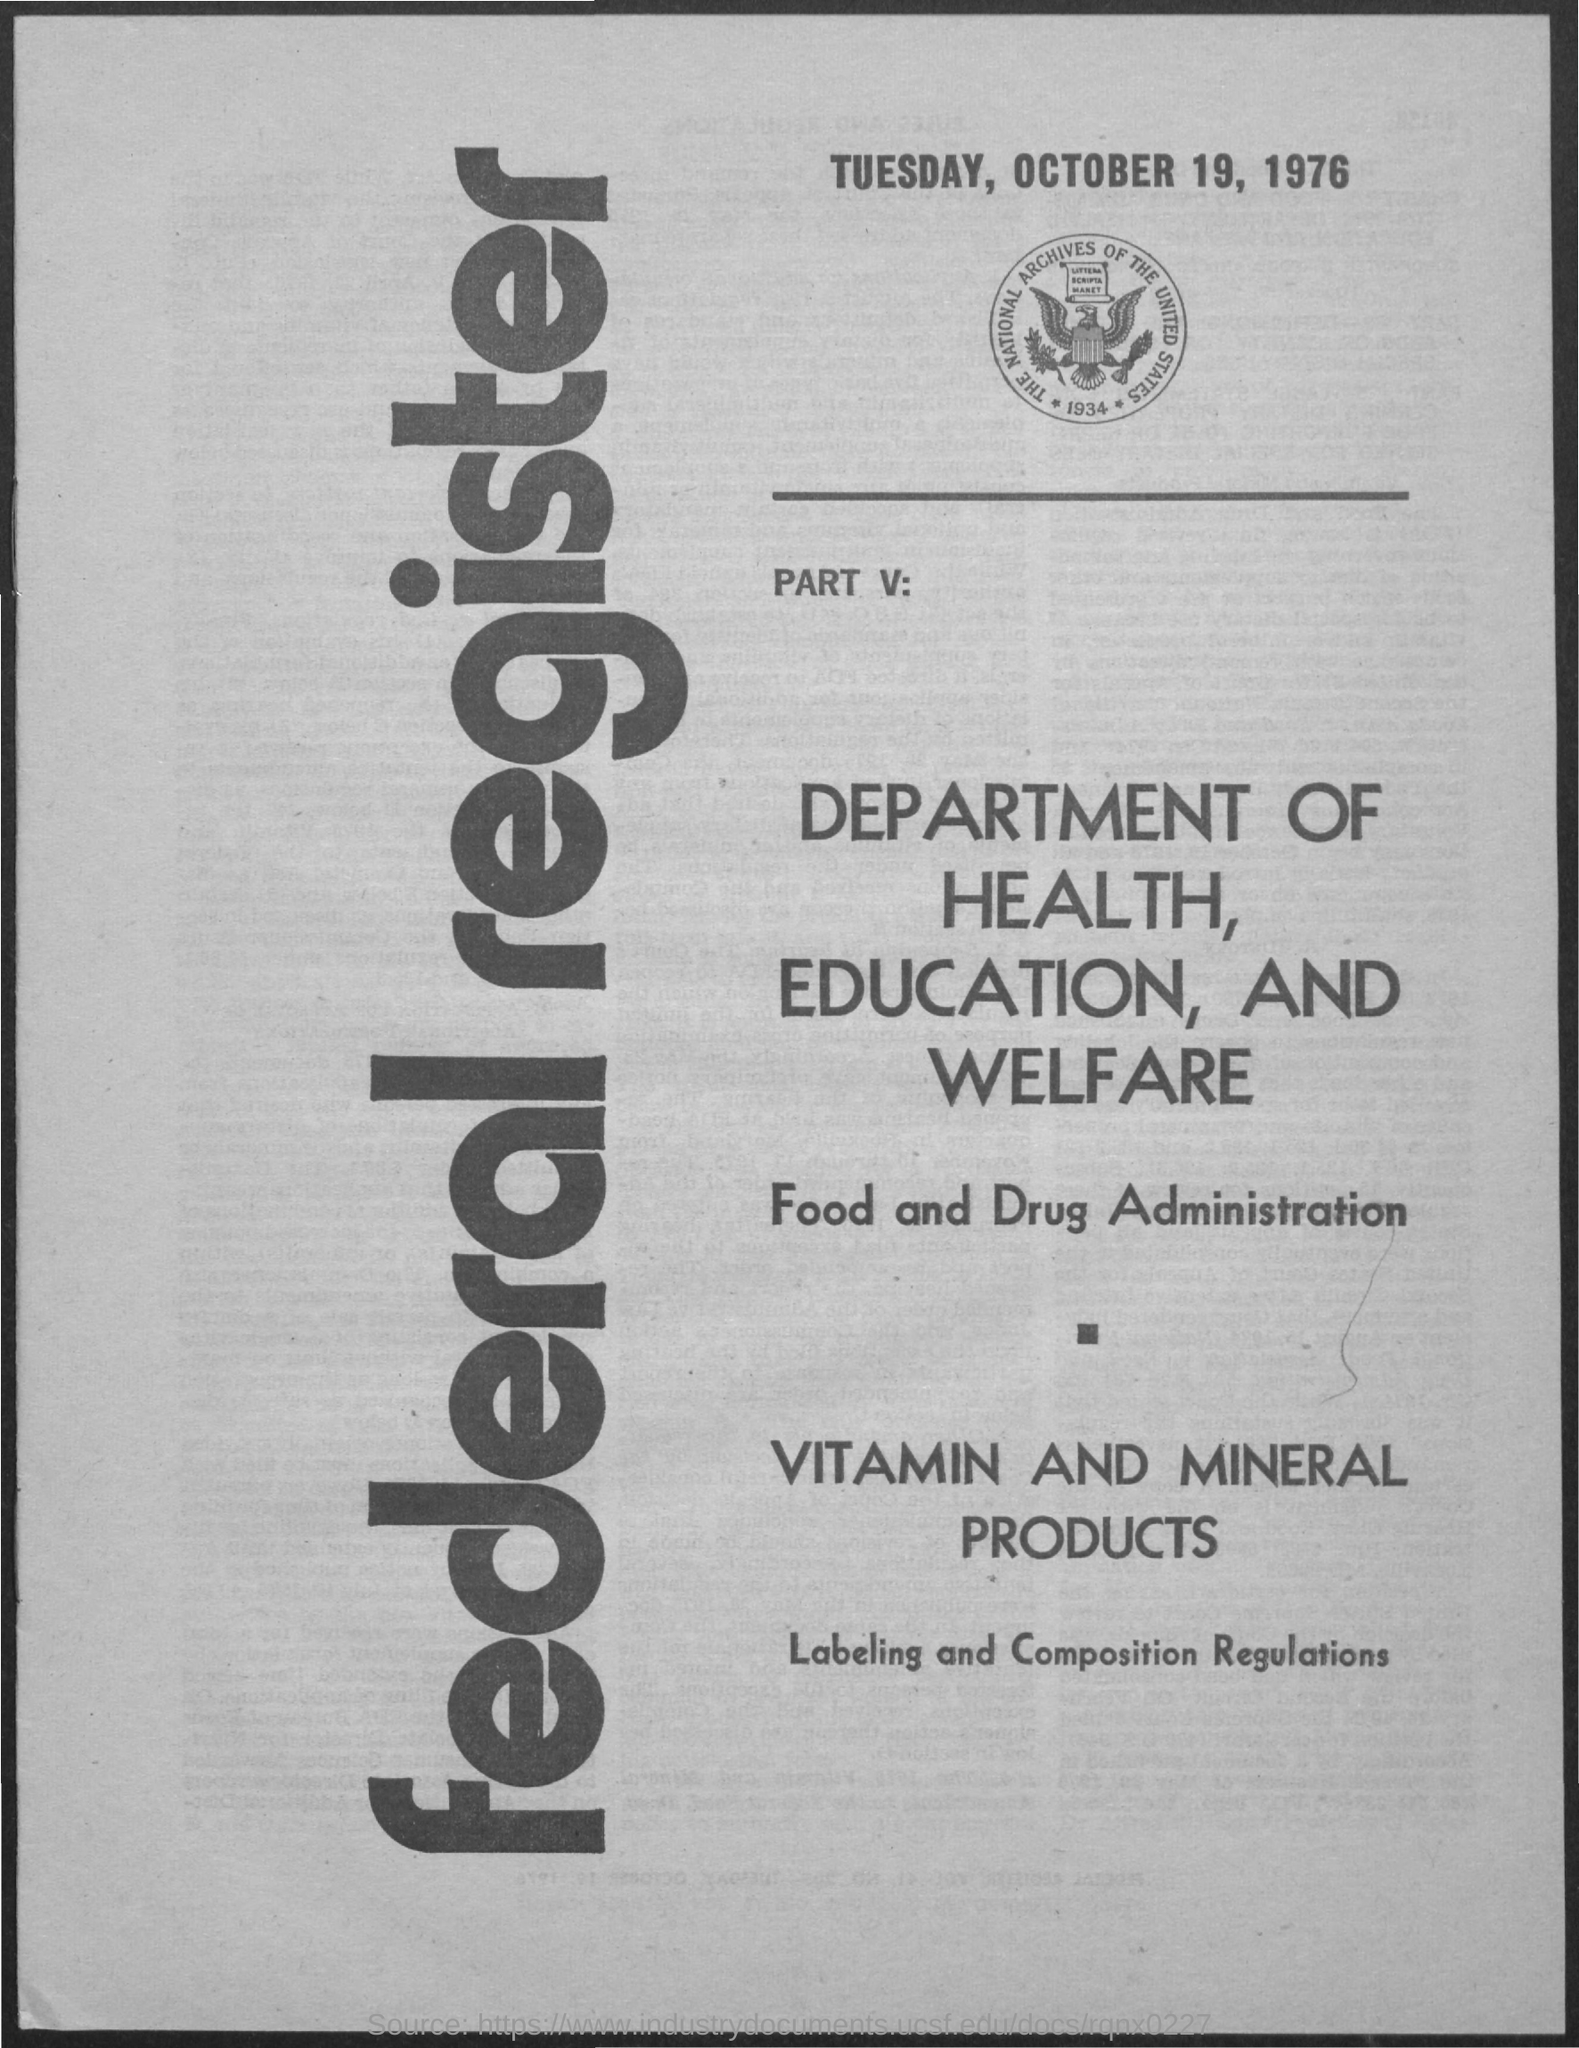What is the date mentioned in the document?
Make the answer very short. Tuesday, October 19, 1976. Which year is below the image?
Make the answer very short. 1934. What is the first title in vertical?
Offer a terse response. Federal register. 